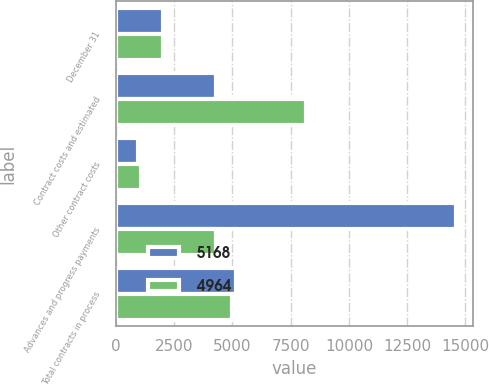<chart> <loc_0><loc_0><loc_500><loc_500><stacked_bar_chart><ecel><fcel>December 31<fcel>Contract costs and estimated<fcel>Other contract costs<fcel>Advances and progress payments<fcel>Total contracts in process<nl><fcel>5168<fcel>2011<fcel>4287<fcel>959<fcel>14598<fcel>5168<nl><fcel>4964<fcel>2012<fcel>8162<fcel>1089<fcel>4287<fcel>4964<nl></chart> 